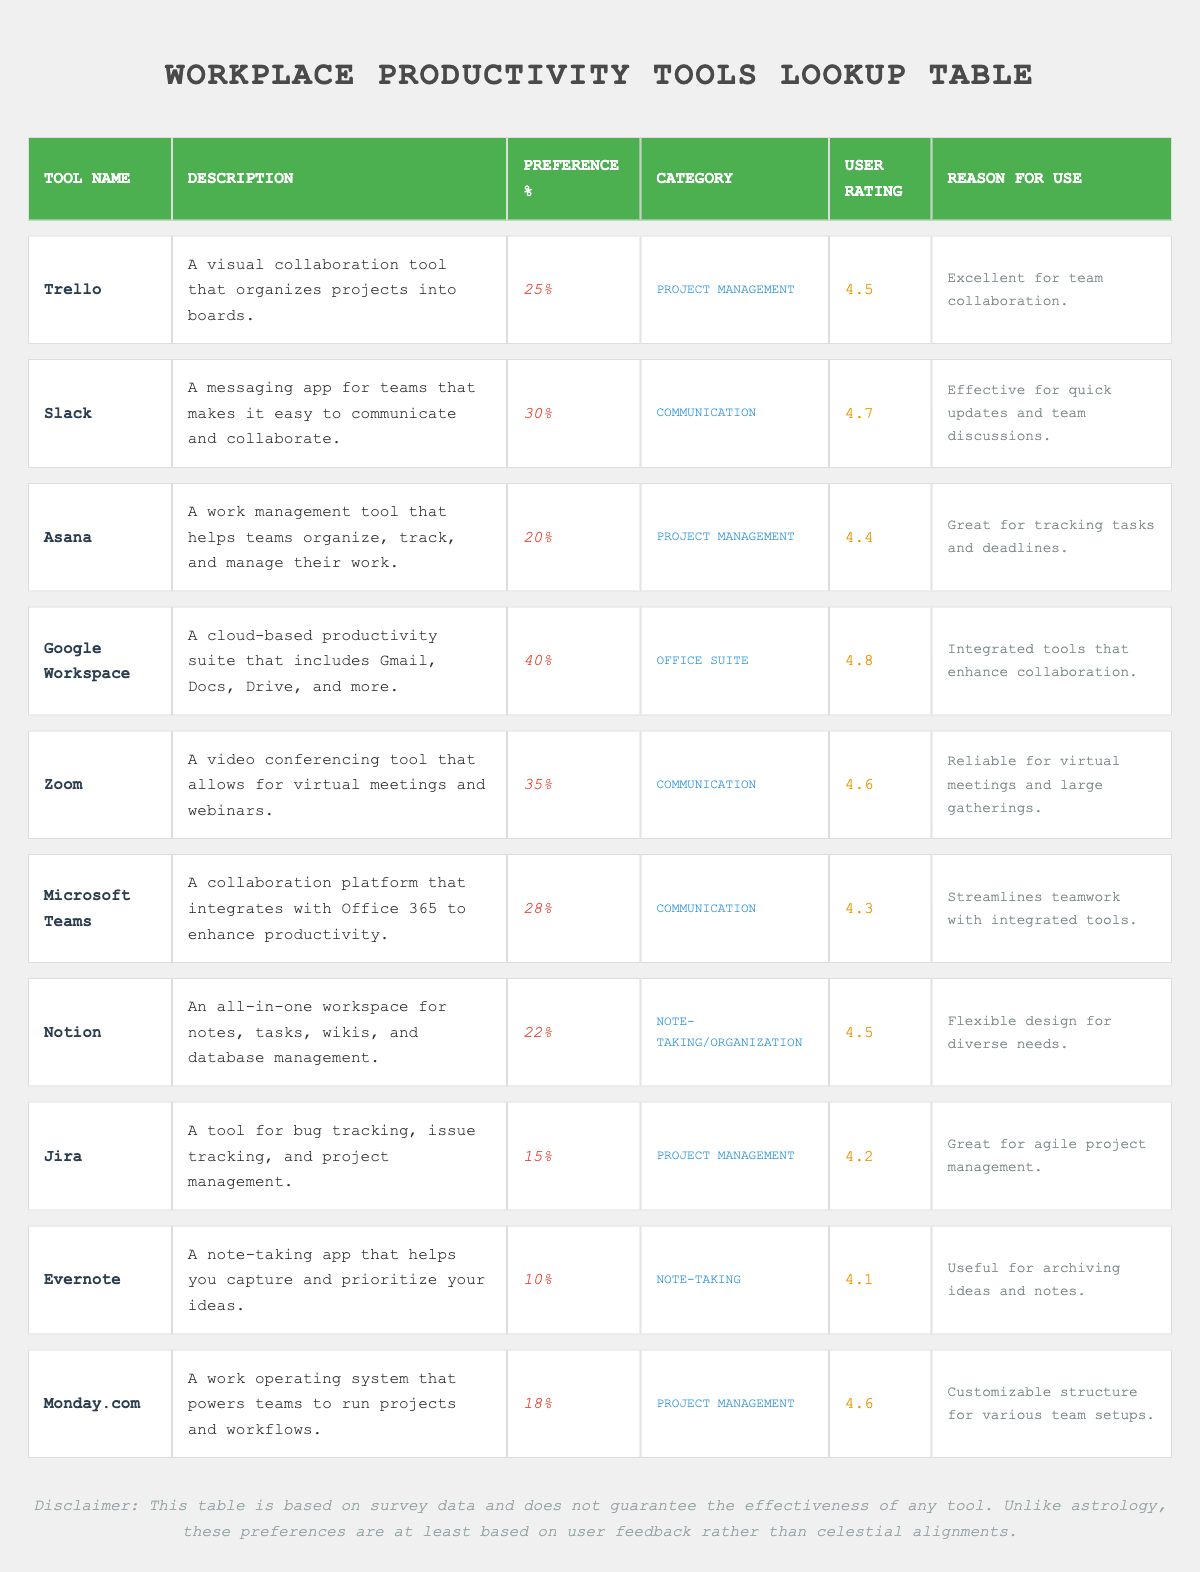What is the user rating of Google Workspace? The table lists Google Workspace, and in the corresponding row, the user rating is specified as 4.8.
Answer: 4.8 Which tool has the highest preference percentage? By comparing the preference percentages in the table, Google Workspace has 40%, which is the highest among all the tools listed.
Answer: Google Workspace What is the combined preference percentage of all Project Management tools? The Project Management tools in the table are Trello (25%), Asana (20%), Jira (15%), and Monday.com (18%). Adding these gives 25 + 20 + 15 + 18 = 78.
Answer: 78 Is Evernote the most preferred note-taking app based on user ratings? Evernote has a user rating of 4.1, while Notion, also a note-taking tool, has a user rating of 4.5. Since Notion has a higher rating, Evernote is not the most preferred.
Answer: No What percentage of respondents prefer communication tools over project management tools? The communication tools are Slack (30%), Zoom (35%), and Microsoft Teams (28%). Their total is 30 + 35 + 28 = 93. Project Management tools are Trello (25%), Asana (20%), Jira (15%), and Monday.com (18%), totaling 25 + 20 + 15 + 18 = 78. Comparing these totals: 93 (communication) - 78 (project management) = 15%.
Answer: 15% 